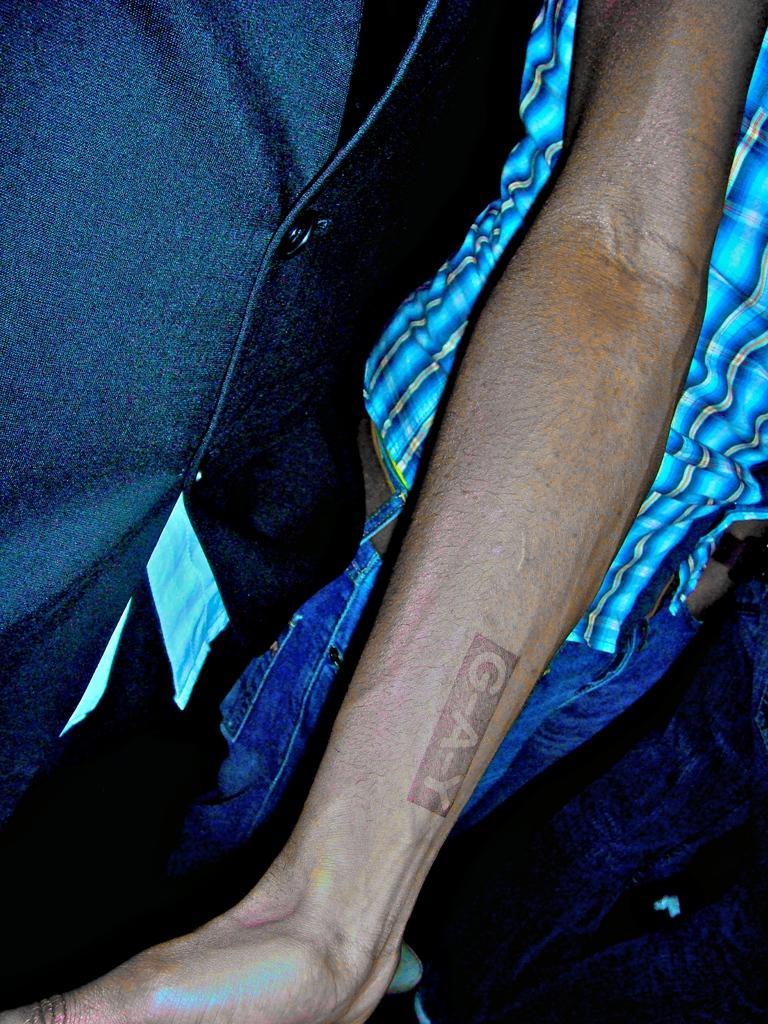Can you describe this image briefly? There is a tattoo on a hand of a person. In the background, there is another person who is in jean pant. 